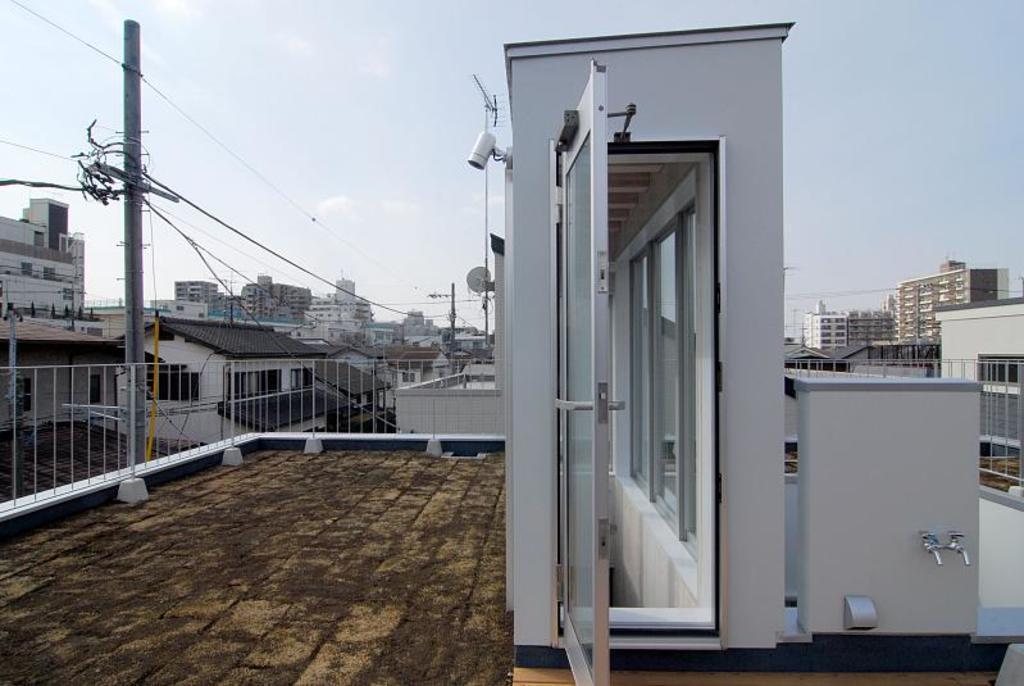In one or two sentences, can you explain what this image depicts? In this image I can see few electric poles and I can also see few buildings in white, brown and cream color, the railing. In the background the sky is in white color. 